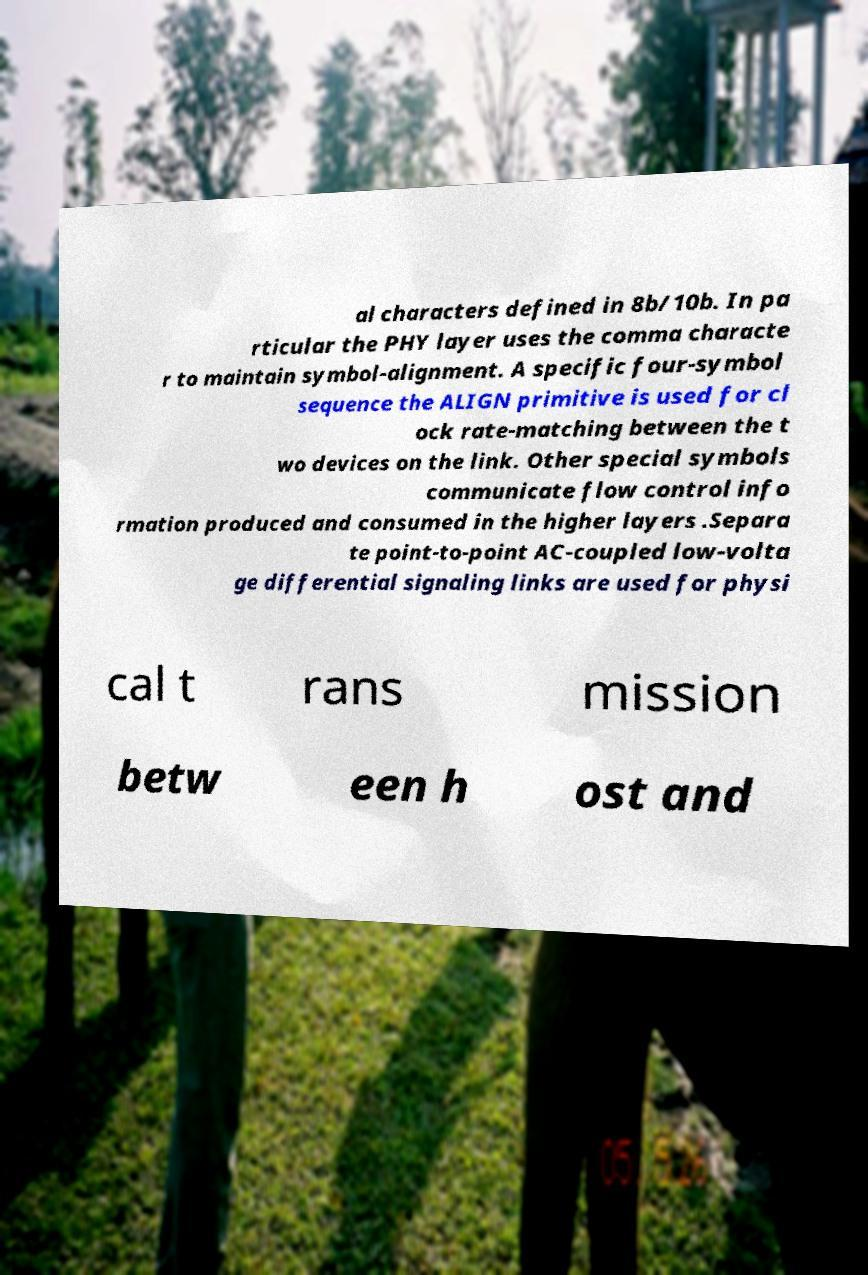What messages or text are displayed in this image? I need them in a readable, typed format. al characters defined in 8b/10b. In pa rticular the PHY layer uses the comma characte r to maintain symbol-alignment. A specific four-symbol sequence the ALIGN primitive is used for cl ock rate-matching between the t wo devices on the link. Other special symbols communicate flow control info rmation produced and consumed in the higher layers .Separa te point-to-point AC-coupled low-volta ge differential signaling links are used for physi cal t rans mission betw een h ost and 